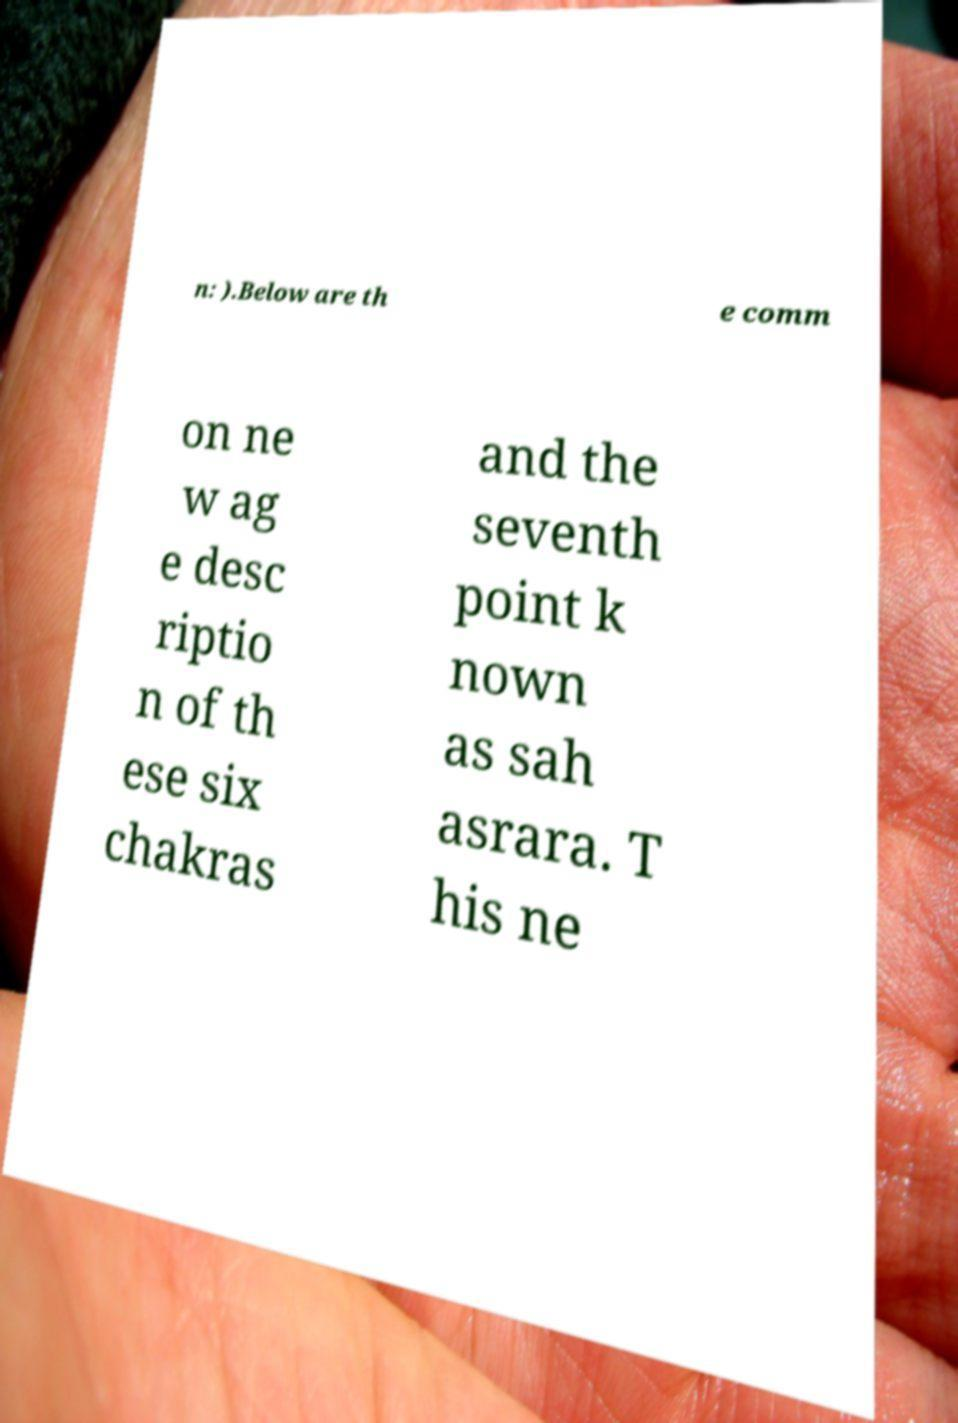There's text embedded in this image that I need extracted. Can you transcribe it verbatim? n: ).Below are th e comm on ne w ag e desc riptio n of th ese six chakras and the seventh point k nown as sah asrara. T his ne 